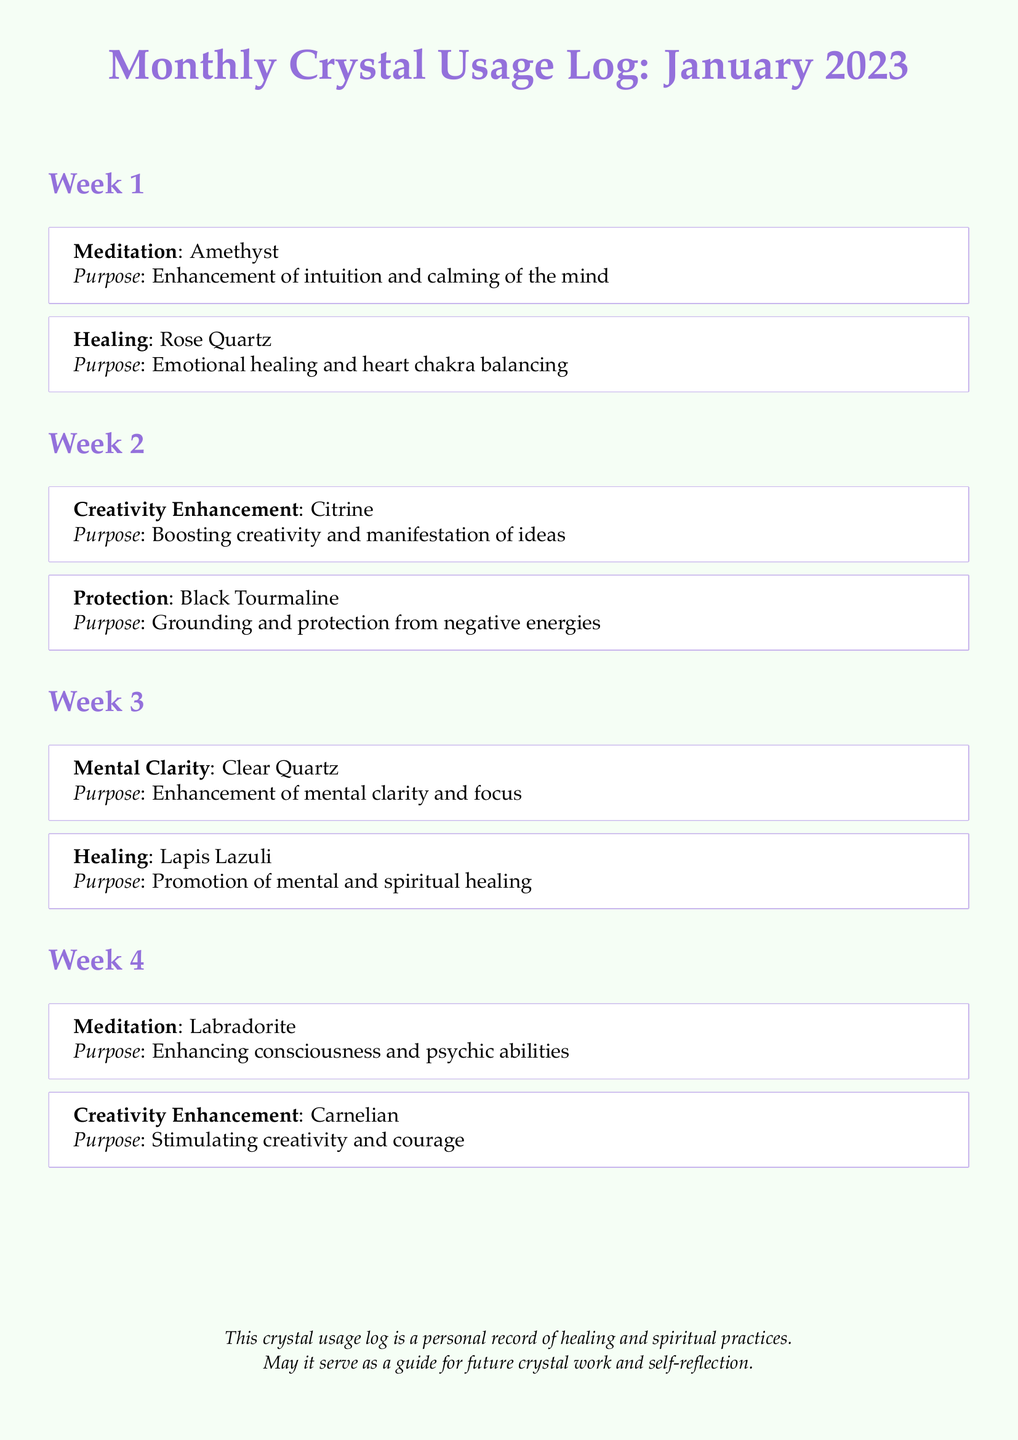What crystal is used for meditation in Week 1? The document states that Amethyst is used for meditation in Week 1.
Answer: Amethyst What is the purpose of Rose Quartz? The document indicates that the purpose of Rose Quartz is emotional healing and heart chakra balancing.
Answer: Emotional healing and heart chakra balancing How many weeks are covered in the Monthly Crystal Usage Log? The document is structured into four weeks, indicating the number of weeks covered is four.
Answer: Four Which crystal is associated with creativity enhancement in Week 2? The document specifies that Citrine is the crystal associated with creativity enhancement in Week 2.
Answer: Citrine What type of purpose is Clear Quartz used for? The document lists the purpose of Clear Quartz as "enhancement of mental clarity and focus."
Answer: Mental clarity Which week features the use of Labradorite for meditation? The document highlights that Labradorite is used for meditation in Week 4.
Answer: Week 4 What type of chakra does Rose Quartz target? The document mentions that Rose Quartz targets the heart chakra.
Answer: Heart chakra What is the overall purpose of the Monthly Crystal Usage Log? The log serves as a personal record of healing and spiritual practices for future guidance.
Answer: Personal record of healing and spiritual practices 